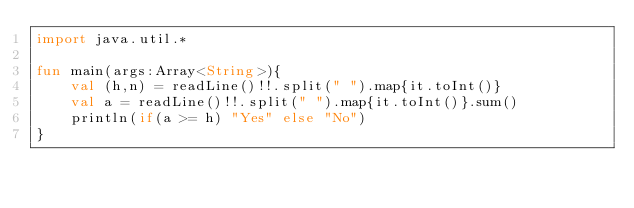Convert code to text. <code><loc_0><loc_0><loc_500><loc_500><_Kotlin_>import java.util.*

fun main(args:Array<String>){
    val (h,n) = readLine()!!.split(" ").map{it.toInt()}
    val a = readLine()!!.split(" ").map{it.toInt()}.sum()
    println(if(a >= h) "Yes" else "No")
}
</code> 